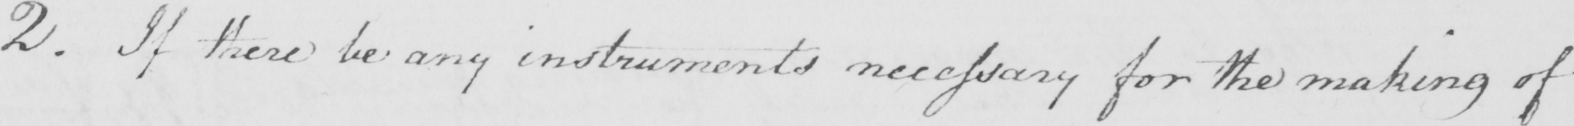What text is written in this handwritten line? 2 . If there be any instruments necessary for the making of 